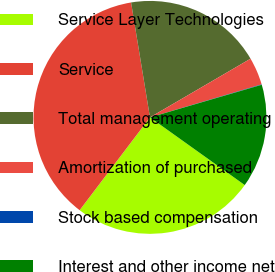Convert chart to OTSL. <chart><loc_0><loc_0><loc_500><loc_500><pie_chart><fcel>Service Layer Technologies<fcel>Service<fcel>Total management operating<fcel>Amortization of purchased<fcel>Stock based compensation<fcel>Interest and other income net<nl><fcel>25.45%<fcel>37.09%<fcel>19.19%<fcel>3.83%<fcel>0.06%<fcel>14.39%<nl></chart> 